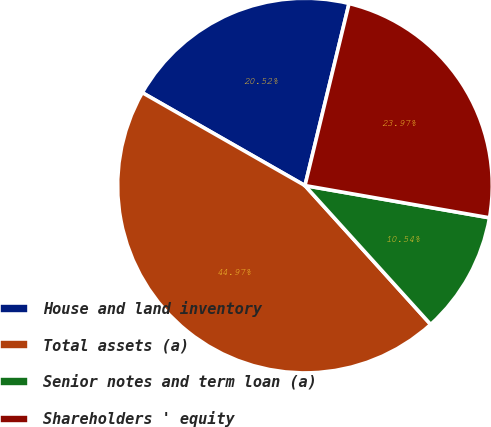<chart> <loc_0><loc_0><loc_500><loc_500><pie_chart><fcel>House and land inventory<fcel>Total assets (a)<fcel>Senior notes and term loan (a)<fcel>Shareholders ' equity<nl><fcel>20.52%<fcel>44.97%<fcel>10.54%<fcel>23.97%<nl></chart> 